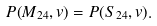Convert formula to latex. <formula><loc_0><loc_0><loc_500><loc_500>P ( M _ { 2 4 } , v ) = P ( S _ { 2 4 } , v ) .</formula> 